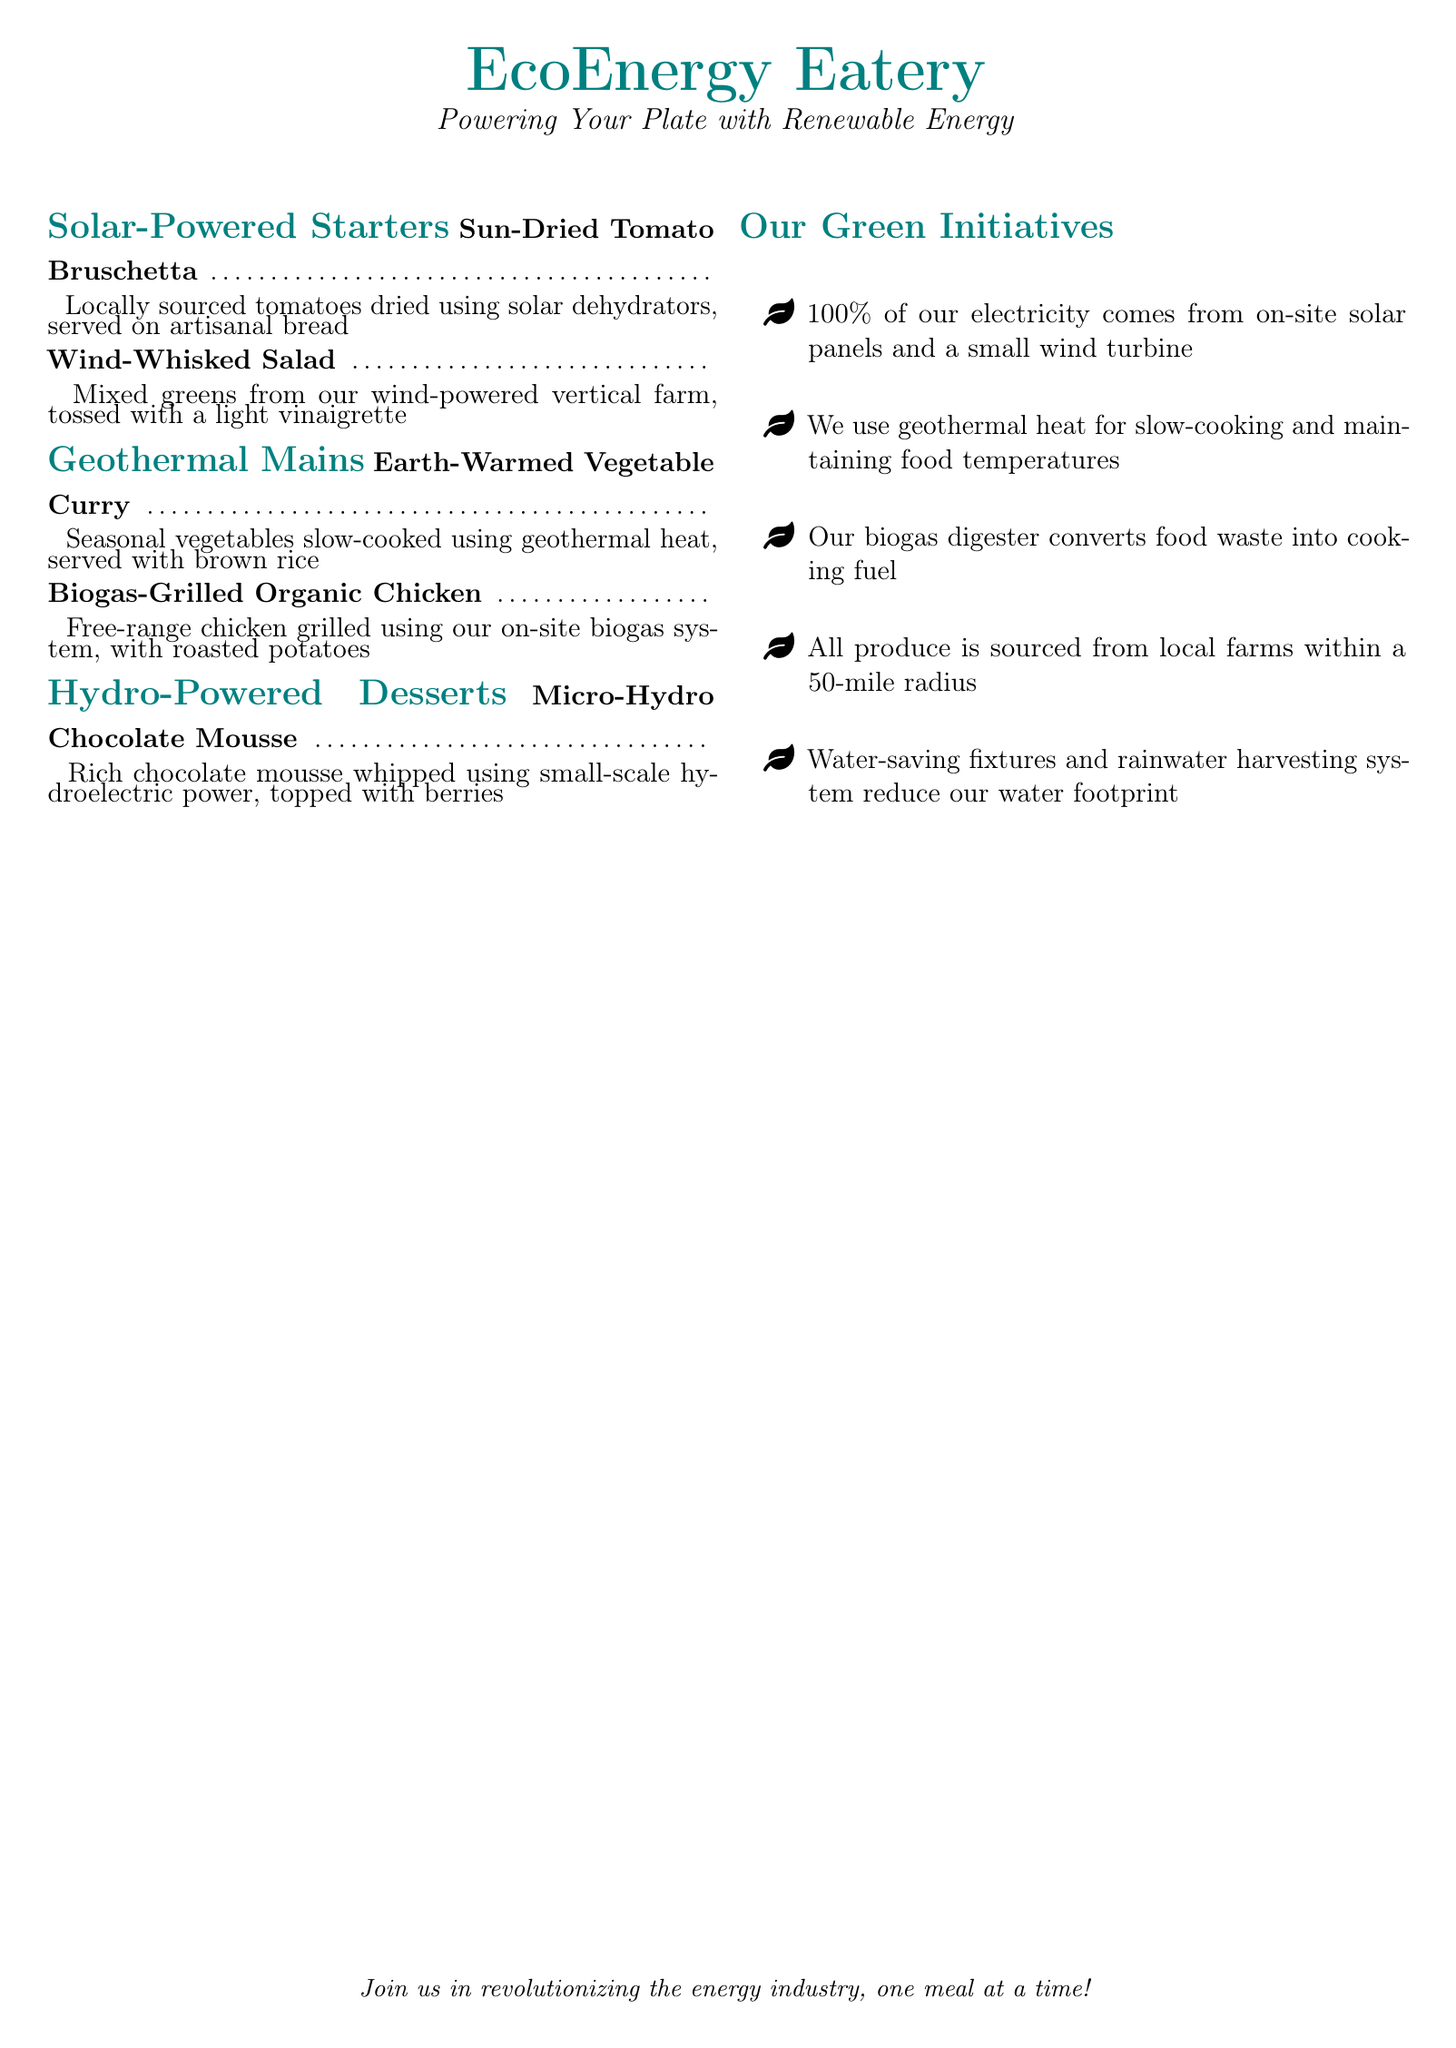What type of energy powers the restaurant? The document states that the restaurant is powered by on-site solar panels and a small wind turbine.
Answer: Solar and wind What is the first dish listed under Solar-Powered Starters? The document lists "Sun-Dried Tomato Bruschetta" as the first dish in that section.
Answer: Sun-Dried Tomato Bruschetta What type of curry is featured in the Geothermal Mains? The dish described in the Geothermal Mains section is an "Earth-Warmed Vegetable Curry."
Answer: Earth-Warmed Vegetable Curry How is the chocolate mousse prepared? The document mentions that the "Micro-Hydro Chocolate Mousse" is whipped using small-scale hydroelectric power.
Answer: Small-scale hydroelectric power What percentage of the restaurant's electricity comes from renewable sources? The restaurant claims that 100% of its electricity comes from renewable sources.
Answer: 100% Which cooking method is used for the biogas-grilled chicken? The preparation method for the chicken is described as being "grilled using our on-site biogas system."
Answer: Biogas system How far are the produce sources located from the restaurant? The document states that all produce is sourced from farms within a 50-mile radius.
Answer: 50 miles What system is used to reduce the water footprint? The initiatives section mentions a "rainwater harvesting system" among other water-saving fixtures.
Answer: Rainwater harvesting system 